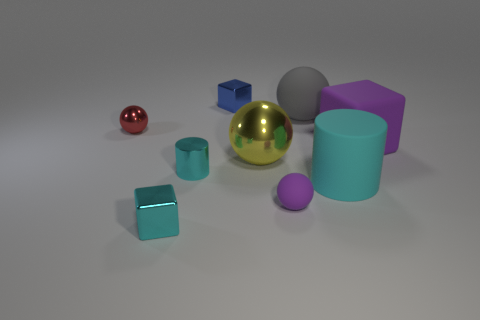Subtract all cyan balls. Subtract all yellow cubes. How many balls are left? 4 Add 1 large blue objects. How many objects exist? 10 Subtract all cylinders. How many objects are left? 7 Add 6 large yellow objects. How many large yellow objects are left? 7 Add 4 cyan shiny blocks. How many cyan shiny blocks exist? 5 Subtract 1 cyan cylinders. How many objects are left? 8 Subtract all yellow balls. Subtract all small yellow spheres. How many objects are left? 8 